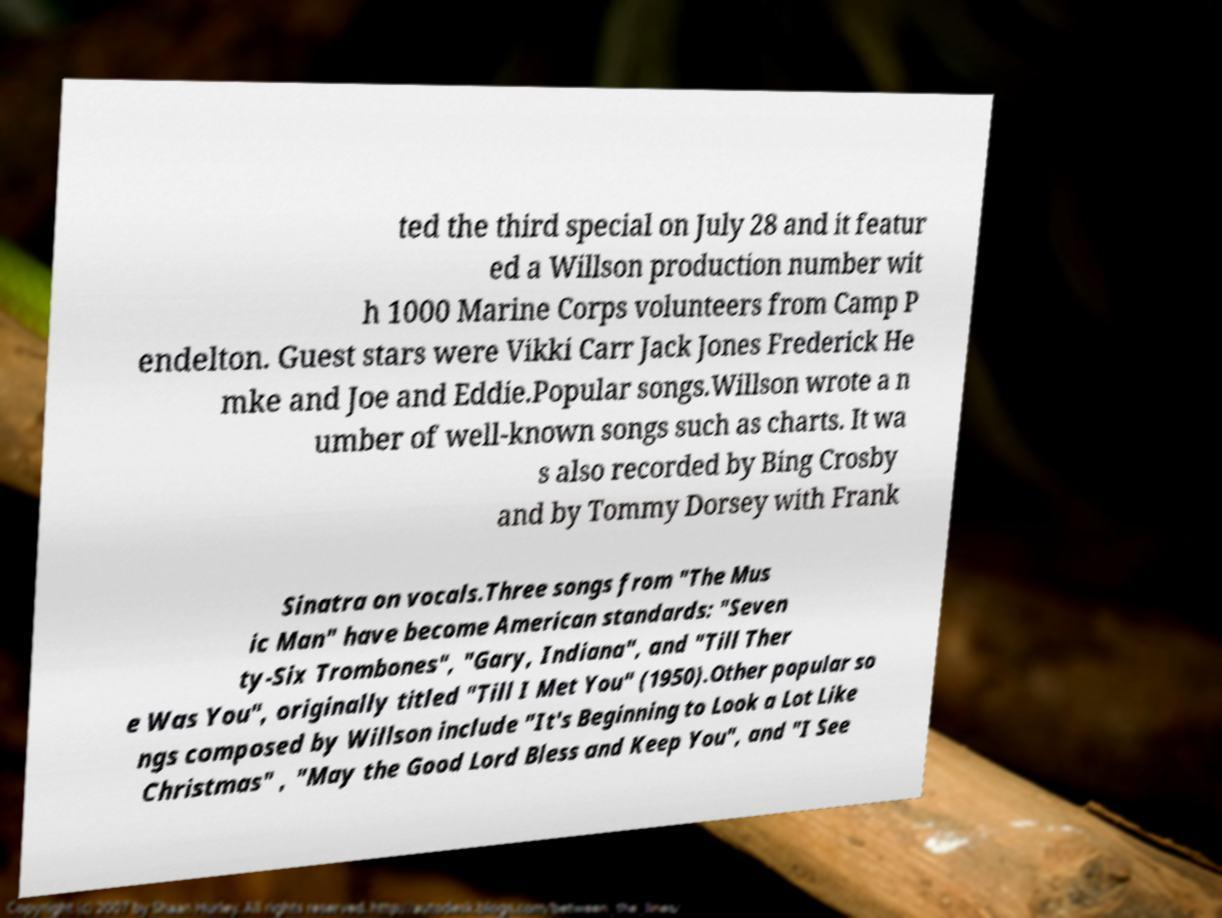Please identify and transcribe the text found in this image. ted the third special on July 28 and it featur ed a Willson production number wit h 1000 Marine Corps volunteers from Camp P endelton. Guest stars were Vikki Carr Jack Jones Frederick He mke and Joe and Eddie.Popular songs.Willson wrote a n umber of well-known songs such as charts. It wa s also recorded by Bing Crosby and by Tommy Dorsey with Frank Sinatra on vocals.Three songs from "The Mus ic Man" have become American standards: "Seven ty-Six Trombones", "Gary, Indiana", and "Till Ther e Was You", originally titled "Till I Met You" (1950).Other popular so ngs composed by Willson include "It's Beginning to Look a Lot Like Christmas" , "May the Good Lord Bless and Keep You", and "I See 